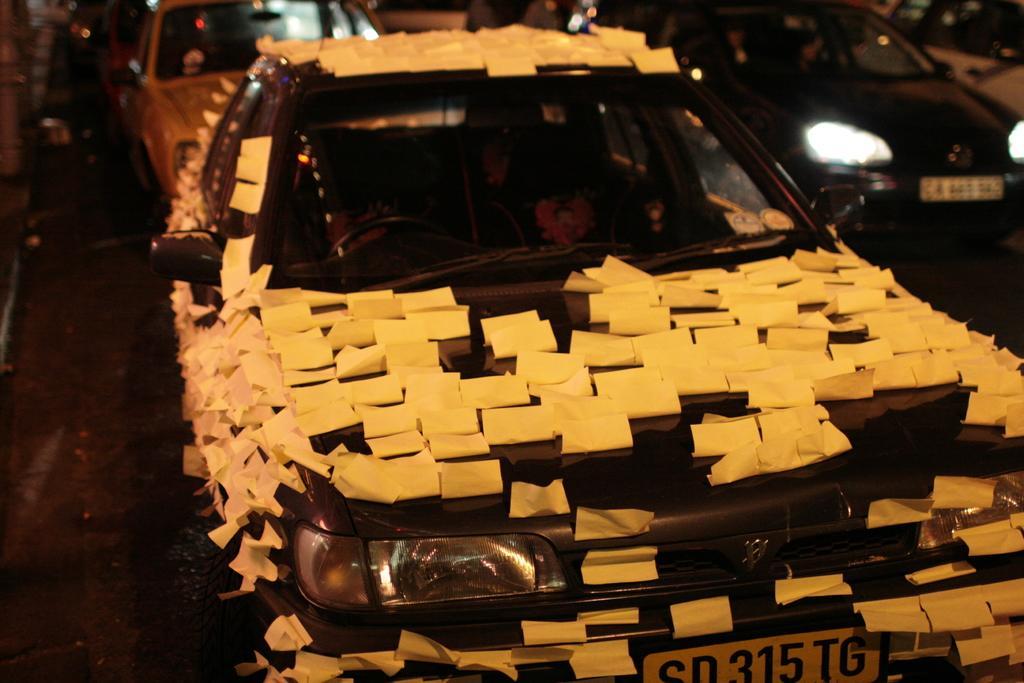In one or two sentences, can you explain what this image depicts? In this image in the front there is a car and on the car there are stickers. In the background there are cars. 